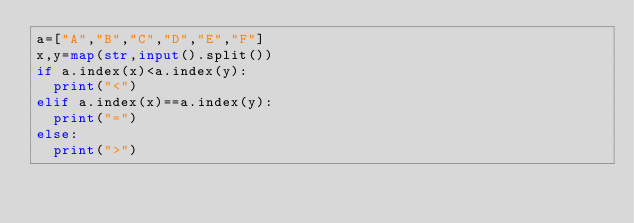<code> <loc_0><loc_0><loc_500><loc_500><_Python_>a=["A","B","C","D","E","F"]
x,y=map(str,input().split())
if a.index(x)<a.index(y):
  print("<")
elif a.index(x)==a.index(y):
  print("=")
else:
  print(">")</code> 